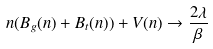Convert formula to latex. <formula><loc_0><loc_0><loc_500><loc_500>n ( B _ { g } ( n ) + B _ { t } ( n ) ) + V ( n ) \rightarrow \frac { 2 \lambda } { \beta }</formula> 